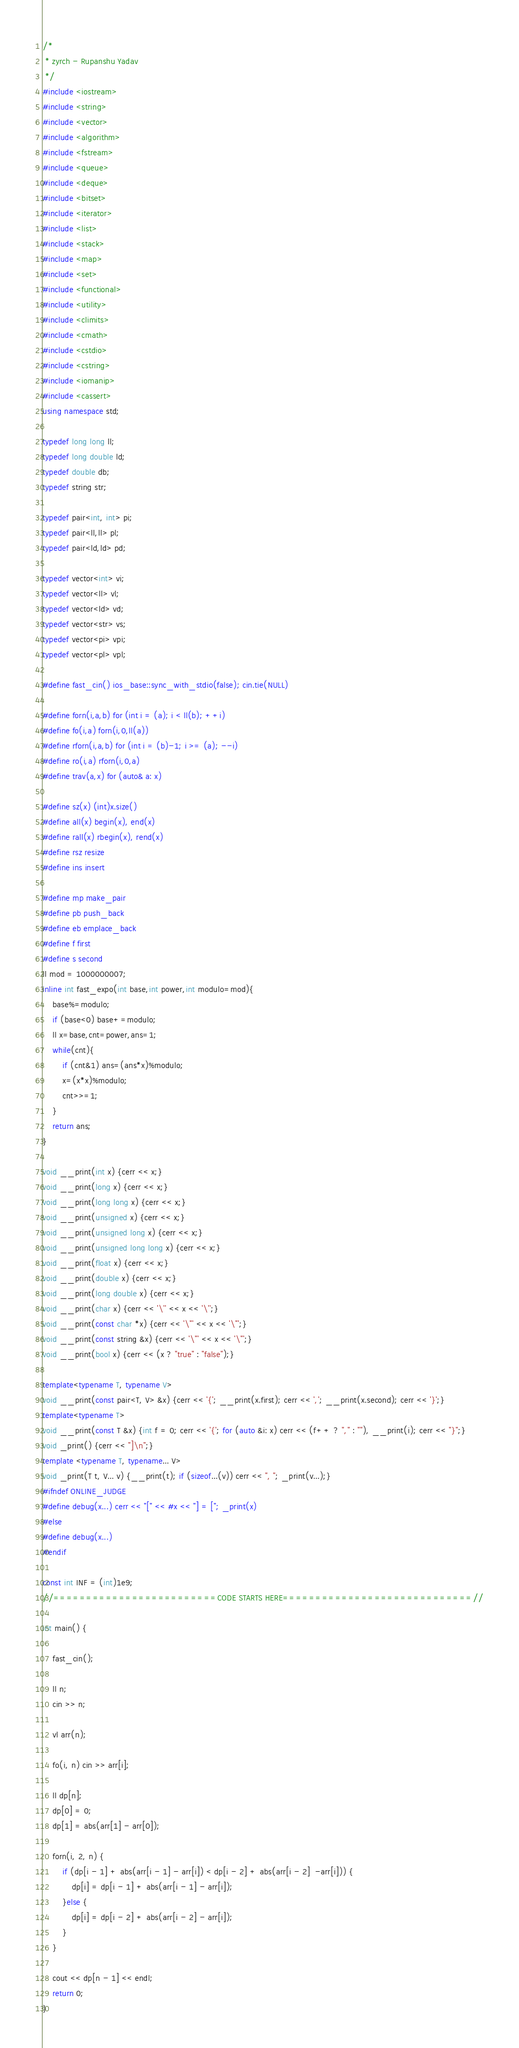<code> <loc_0><loc_0><loc_500><loc_500><_C++_>/*
 * zyrch - Rupanshu Yadav
 */
#include <iostream>
#include <string>
#include <vector>
#include <algorithm>
#include <fstream>
#include <queue>
#include <deque>
#include <bitset>
#include <iterator>
#include <list>
#include <stack>
#include <map>
#include <set>
#include <functional>
#include <utility>
#include <climits>
#include <cmath>
#include <cstdio>
#include <cstring>
#include <iomanip>
#include <cassert>
using namespace std;

typedef long long ll;
typedef long double ld;
typedef double db;
typedef string str;

typedef pair<int, int> pi;
typedef pair<ll,ll> pl;
typedef pair<ld,ld> pd;

typedef vector<int> vi;
typedef vector<ll> vl;
typedef vector<ld> vd;
typedef vector<str> vs;
typedef vector<pi> vpi;
typedef vector<pl> vpl;

#define fast_cin() ios_base::sync_with_stdio(false); cin.tie(NULL)

#define forn(i,a,b) for (int i = (a); i < ll(b); ++i)
#define fo(i,a) forn(i,0,ll(a))
#define rforn(i,a,b) for (int i = (b)-1; i >= (a); --i)
#define ro(i,a) rforn(i,0,a)
#define trav(a,x) for (auto& a: x)

#define sz(x) (int)x.size()
#define all(x) begin(x), end(x)
#define rall(x) rbegin(x), rend(x)
#define rsz resize
#define ins insert

#define mp make_pair
#define pb push_back
#define eb emplace_back
#define f first
#define s second
ll mod = 1000000007;
inline int fast_expo(int base,int power,int modulo=mod){
    base%=modulo;
    if (base<0) base+=modulo;
    ll x=base,cnt=power,ans=1;
    while(cnt){
        if (cnt&1) ans=(ans*x)%modulo;
        x=(x*x)%modulo;
        cnt>>=1;
    }
    return ans;
}

void __print(int x) {cerr << x;}
void __print(long x) {cerr << x;}
void __print(long long x) {cerr << x;}
void __print(unsigned x) {cerr << x;}
void __print(unsigned long x) {cerr << x;}
void __print(unsigned long long x) {cerr << x;}
void __print(float x) {cerr << x;}
void __print(double x) {cerr << x;}
void __print(long double x) {cerr << x;}
void __print(char x) {cerr << '\'' << x << '\'';}
void __print(const char *x) {cerr << '\"' << x << '\"';}
void __print(const string &x) {cerr << '\"' << x << '\"';}
void __print(bool x) {cerr << (x ? "true" : "false");}

template<typename T, typename V>
void __print(const pair<T, V> &x) {cerr << '{'; __print(x.first); cerr << ','; __print(x.second); cerr << '}';}
template<typename T>
void __print(const T &x) {int f = 0; cerr << '{'; for (auto &i: x) cerr << (f++ ? "," : ""), __print(i); cerr << "}";}
void _print() {cerr << "]\n";}
template <typename T, typename... V>
void _print(T t, V... v) {__print(t); if (sizeof...(v)) cerr << ", "; _print(v...);}
#ifndef ONLINE_JUDGE
#define debug(x...) cerr << "[" << #x << "] = ["; _print(x)
#else
#define debug(x...)
#endif

const int INF = (int)1e9;
//=========================CODE STARTS HERE=============================//

int main() {

	fast_cin();

	ll n;
	cin >> n;
	
	vl arr(n);
	
	fo(i, n) cin >> arr[i];
	
	ll dp[n];
	dp[0] = 0;
	dp[1] = abs(arr[1] - arr[0]);
	
	forn(i, 2, n) {
		if (dp[i - 1] + abs(arr[i - 1] - arr[i]) < dp[i - 2] + abs(arr[i - 2]  -arr[i])) {
			dp[i] = dp[i - 1] + abs(arr[i - 1] - arr[i]);
		}else {
			dp[i] = dp[i - 2] + abs(arr[i - 2] - arr[i]);
		}
	}
	
	cout << dp[n - 1] << endl;
    return 0;
}
</code> 